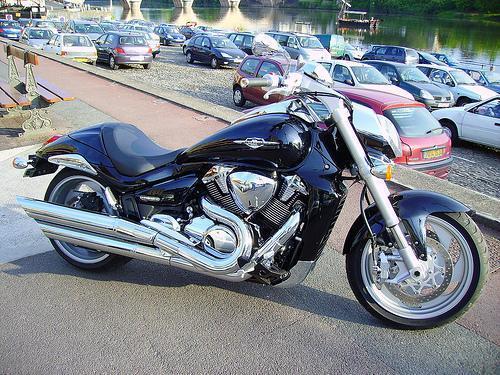How many bikes are there?
Give a very brief answer. 1. 